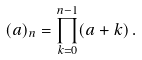Convert formula to latex. <formula><loc_0><loc_0><loc_500><loc_500>( a ) _ { n } = \prod _ { k = 0 } ^ { n - 1 } ( a + k ) \, .</formula> 